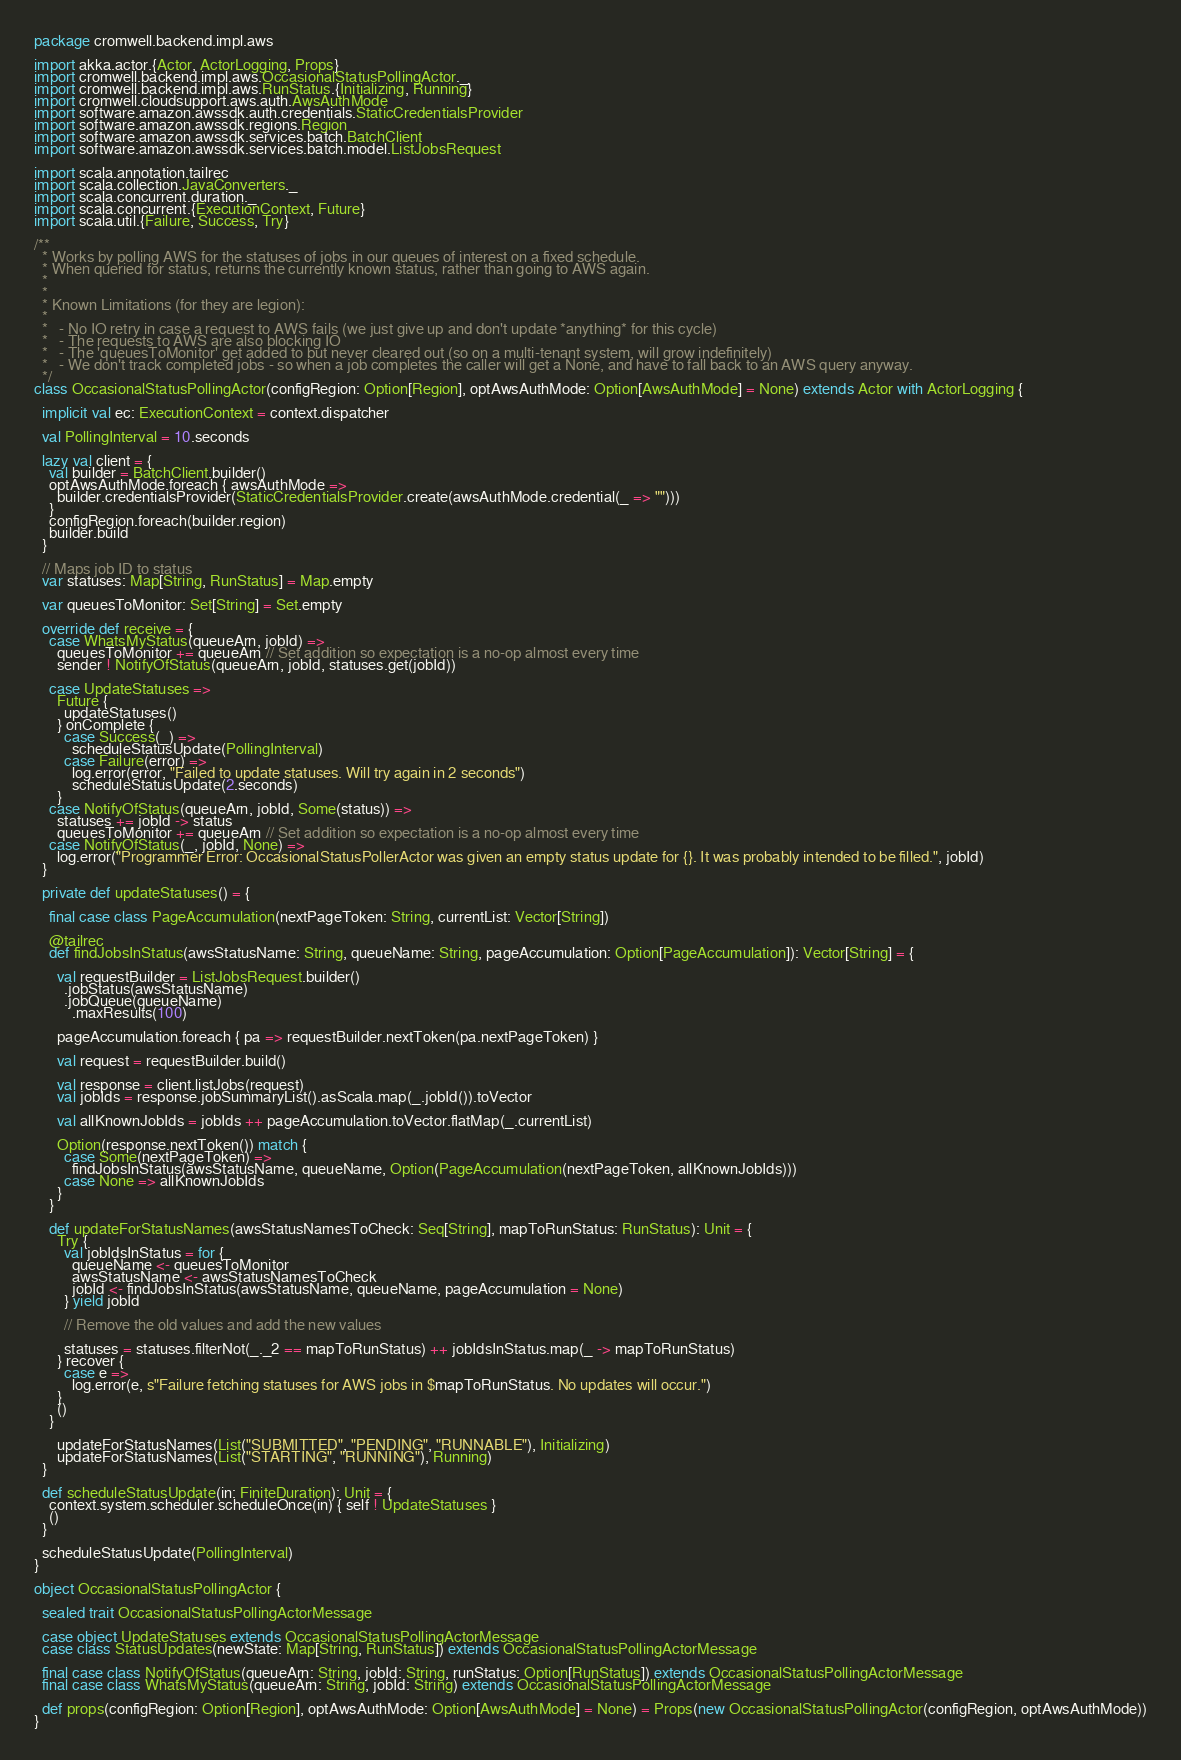<code> <loc_0><loc_0><loc_500><loc_500><_Scala_>package cromwell.backend.impl.aws

import akka.actor.{Actor, ActorLogging, Props}
import cromwell.backend.impl.aws.OccasionalStatusPollingActor._
import cromwell.backend.impl.aws.RunStatus.{Initializing, Running}
import cromwell.cloudsupport.aws.auth.AwsAuthMode
import software.amazon.awssdk.auth.credentials.StaticCredentialsProvider
import software.amazon.awssdk.regions.Region
import software.amazon.awssdk.services.batch.BatchClient
import software.amazon.awssdk.services.batch.model.ListJobsRequest

import scala.annotation.tailrec
import scala.collection.JavaConverters._
import scala.concurrent.duration._
import scala.concurrent.{ExecutionContext, Future}
import scala.util.{Failure, Success, Try}

/**
  * Works by polling AWS for the statuses of jobs in our queues of interest on a fixed schedule.
  * When queried for status, returns the currently known status, rather than going to AWS again.
  *
  *
  * Known Limitations (for they are legion):
  *
  *   - No IO retry in case a request to AWS fails (we just give up and don't update *anything* for this cycle)
  *   - The requests to AWS are also blocking IO
  *   - The 'queuesToMonitor' get added to but never cleared out (so on a multi-tenant system, will grow indefinitely)
  *   - We don't track completed jobs - so when a job completes the caller will get a None, and have to fall back to an AWS query anyway.
  */
class OccasionalStatusPollingActor(configRegion: Option[Region], optAwsAuthMode: Option[AwsAuthMode] = None) extends Actor with ActorLogging {

  implicit val ec: ExecutionContext = context.dispatcher

  val PollingInterval = 10.seconds

  lazy val client = {
    val builder = BatchClient.builder()
    optAwsAuthMode.foreach { awsAuthMode =>
      builder.credentialsProvider(StaticCredentialsProvider.create(awsAuthMode.credential(_ => "")))
    }
    configRegion.foreach(builder.region)
    builder.build
  }

  // Maps job ID to status
  var statuses: Map[String, RunStatus] = Map.empty

  var queuesToMonitor: Set[String] = Set.empty

  override def receive = {
    case WhatsMyStatus(queueArn, jobId) =>
      queuesToMonitor += queueArn // Set addition so expectation is a no-op almost every time
      sender ! NotifyOfStatus(queueArn, jobId, statuses.get(jobId))

    case UpdateStatuses =>
      Future {
        updateStatuses()
      } onComplete {
        case Success(_) =>
          scheduleStatusUpdate(PollingInterval)
        case Failure(error) =>
          log.error(error, "Failed to update statuses. Will try again in 2 seconds")
          scheduleStatusUpdate(2.seconds)
      }
    case NotifyOfStatus(queueArn, jobId, Some(status)) =>
      statuses += jobId -> status
      queuesToMonitor += queueArn // Set addition so expectation is a no-op almost every time
    case NotifyOfStatus(_, jobId, None) =>
      log.error("Programmer Error: OccasionalStatusPollerActor was given an empty status update for {}. It was probably intended to be filled.", jobId)
  }

  private def updateStatuses() = {

    final case class PageAccumulation(nextPageToken: String, currentList: Vector[String])

    @tailrec
    def findJobsInStatus(awsStatusName: String, queueName: String, pageAccumulation: Option[PageAccumulation]): Vector[String] = {

      val requestBuilder = ListJobsRequest.builder()
        .jobStatus(awsStatusName)
        .jobQueue(queueName)
          .maxResults(100)

      pageAccumulation.foreach { pa => requestBuilder.nextToken(pa.nextPageToken) }

      val request = requestBuilder.build()

      val response = client.listJobs(request)
      val jobIds = response.jobSummaryList().asScala.map(_.jobId()).toVector

      val allKnownJobIds = jobIds ++ pageAccumulation.toVector.flatMap(_.currentList)

      Option(response.nextToken()) match {
        case Some(nextPageToken) =>
          findJobsInStatus(awsStatusName, queueName, Option(PageAccumulation(nextPageToken, allKnownJobIds)))
        case None => allKnownJobIds
      }
    }

    def updateForStatusNames(awsStatusNamesToCheck: Seq[String], mapToRunStatus: RunStatus): Unit = {
      Try {
        val jobIdsInStatus = for {
          queueName <- queuesToMonitor
          awsStatusName <- awsStatusNamesToCheck
          jobId <- findJobsInStatus(awsStatusName, queueName, pageAccumulation = None)
        } yield jobId

        // Remove the old values and add the new values

        statuses = statuses.filterNot(_._2 == mapToRunStatus) ++ jobIdsInStatus.map(_ -> mapToRunStatus)
      } recover {
        case e =>
          log.error(e, s"Failure fetching statuses for AWS jobs in $mapToRunStatus. No updates will occur.")
      }
      ()
    }

      updateForStatusNames(List("SUBMITTED", "PENDING", "RUNNABLE"), Initializing)
      updateForStatusNames(List("STARTING", "RUNNING"), Running)
  }

  def scheduleStatusUpdate(in: FiniteDuration): Unit = {
    context.system.scheduler.scheduleOnce(in) { self ! UpdateStatuses }
    ()
  }

  scheduleStatusUpdate(PollingInterval)
}

object OccasionalStatusPollingActor {

  sealed trait OccasionalStatusPollingActorMessage

  case object UpdateStatuses extends OccasionalStatusPollingActorMessage
  case class StatusUpdates(newState: Map[String, RunStatus]) extends OccasionalStatusPollingActorMessage

  final case class NotifyOfStatus(queueArn: String, jobId: String, runStatus: Option[RunStatus]) extends OccasionalStatusPollingActorMessage
  final case class WhatsMyStatus(queueArn: String, jobId: String) extends OccasionalStatusPollingActorMessage

  def props(configRegion: Option[Region], optAwsAuthMode: Option[AwsAuthMode] = None) = Props(new OccasionalStatusPollingActor(configRegion, optAwsAuthMode))
}
</code> 